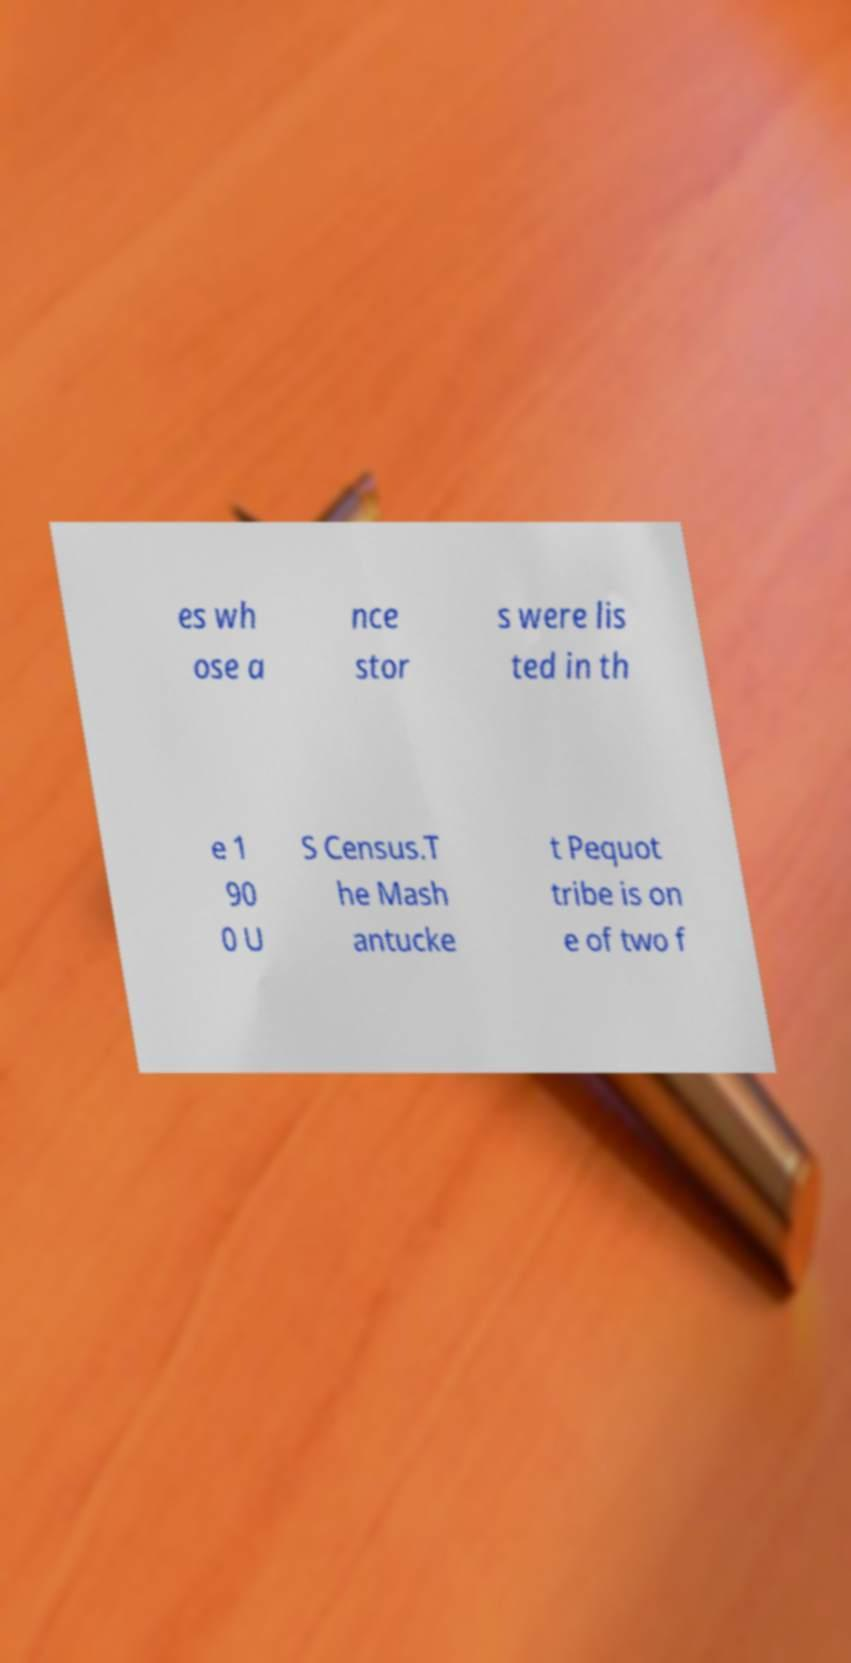There's text embedded in this image that I need extracted. Can you transcribe it verbatim? es wh ose a nce stor s were lis ted in th e 1 90 0 U S Census.T he Mash antucke t Pequot tribe is on e of two f 